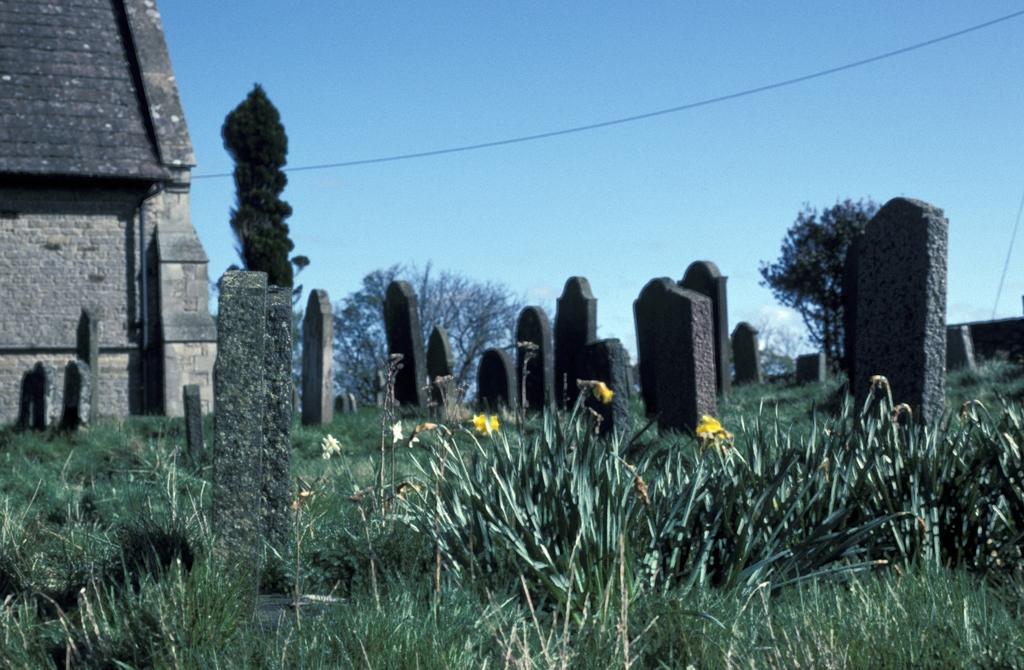How would you summarize this image in a sentence or two? In this image I can see few flowers in yellow color, grass in green color, symmetries. Background I can see a building in cream color, trees in green color and the sky is in blue color. 